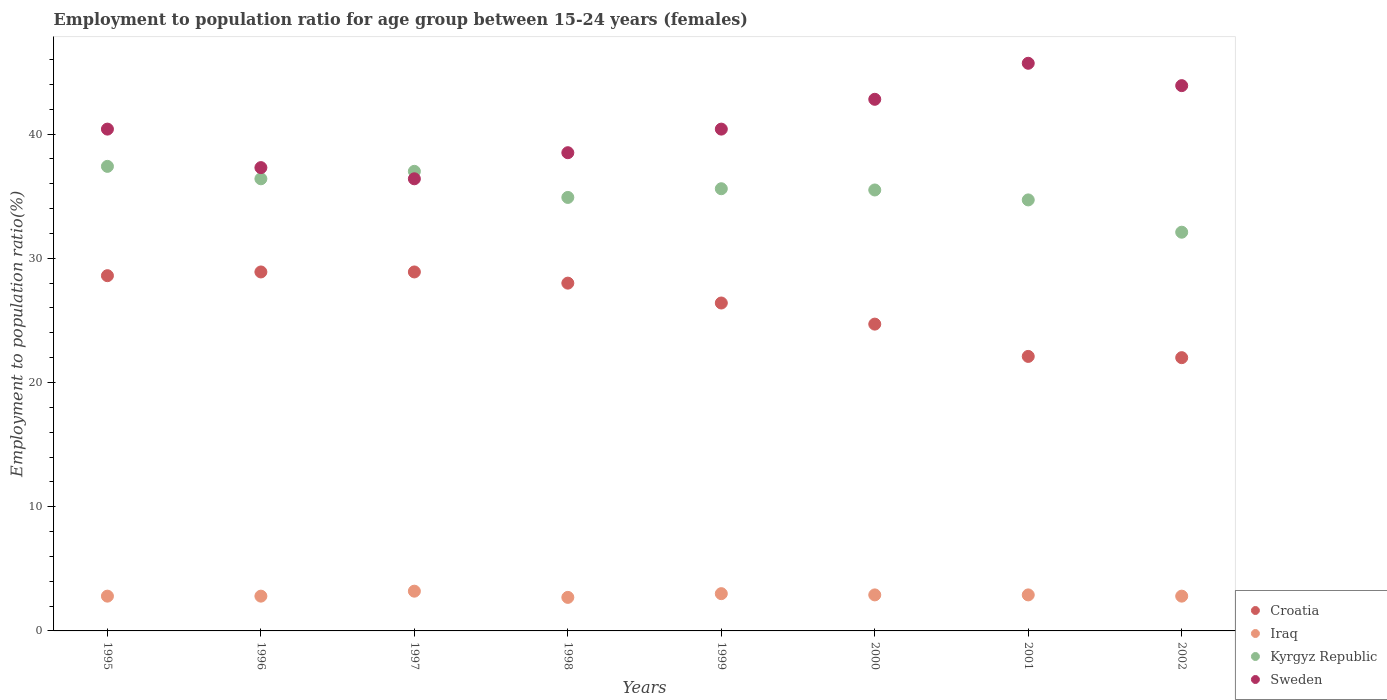Is the number of dotlines equal to the number of legend labels?
Provide a succinct answer. Yes. What is the employment to population ratio in Kyrgyz Republic in 1998?
Offer a terse response. 34.9. Across all years, what is the maximum employment to population ratio in Croatia?
Provide a succinct answer. 28.9. Across all years, what is the minimum employment to population ratio in Croatia?
Offer a very short reply. 22. In which year was the employment to population ratio in Iraq minimum?
Provide a succinct answer. 1998. What is the total employment to population ratio in Sweden in the graph?
Provide a short and direct response. 325.4. What is the difference between the employment to population ratio in Kyrgyz Republic in 2000 and that in 2001?
Provide a short and direct response. 0.8. What is the difference between the employment to population ratio in Kyrgyz Republic in 1997 and the employment to population ratio in Iraq in 2001?
Offer a very short reply. 34.1. What is the average employment to population ratio in Kyrgyz Republic per year?
Your response must be concise. 35.45. In the year 1996, what is the difference between the employment to population ratio in Croatia and employment to population ratio in Sweden?
Provide a succinct answer. -8.4. What is the ratio of the employment to population ratio in Croatia in 1996 to that in 2001?
Give a very brief answer. 1.31. Is the employment to population ratio in Iraq in 1998 less than that in 2002?
Keep it short and to the point. Yes. What is the difference between the highest and the second highest employment to population ratio in Sweden?
Provide a short and direct response. 1.8. What is the difference between the highest and the lowest employment to population ratio in Kyrgyz Republic?
Provide a succinct answer. 5.3. In how many years, is the employment to population ratio in Kyrgyz Republic greater than the average employment to population ratio in Kyrgyz Republic taken over all years?
Make the answer very short. 5. Is it the case that in every year, the sum of the employment to population ratio in Iraq and employment to population ratio in Kyrgyz Republic  is greater than the sum of employment to population ratio in Croatia and employment to population ratio in Sweden?
Make the answer very short. No. Is the employment to population ratio in Sweden strictly greater than the employment to population ratio in Kyrgyz Republic over the years?
Your answer should be very brief. No. How many dotlines are there?
Provide a succinct answer. 4. What is the difference between two consecutive major ticks on the Y-axis?
Make the answer very short. 10. Are the values on the major ticks of Y-axis written in scientific E-notation?
Keep it short and to the point. No. How are the legend labels stacked?
Provide a short and direct response. Vertical. What is the title of the graph?
Your answer should be very brief. Employment to population ratio for age group between 15-24 years (females). What is the label or title of the X-axis?
Your answer should be compact. Years. What is the Employment to population ratio(%) of Croatia in 1995?
Give a very brief answer. 28.6. What is the Employment to population ratio(%) in Iraq in 1995?
Offer a very short reply. 2.8. What is the Employment to population ratio(%) in Kyrgyz Republic in 1995?
Your answer should be very brief. 37.4. What is the Employment to population ratio(%) in Sweden in 1995?
Your response must be concise. 40.4. What is the Employment to population ratio(%) of Croatia in 1996?
Your answer should be very brief. 28.9. What is the Employment to population ratio(%) of Iraq in 1996?
Ensure brevity in your answer.  2.8. What is the Employment to population ratio(%) in Kyrgyz Republic in 1996?
Your response must be concise. 36.4. What is the Employment to population ratio(%) in Sweden in 1996?
Your answer should be compact. 37.3. What is the Employment to population ratio(%) in Croatia in 1997?
Provide a succinct answer. 28.9. What is the Employment to population ratio(%) of Iraq in 1997?
Ensure brevity in your answer.  3.2. What is the Employment to population ratio(%) of Sweden in 1997?
Offer a terse response. 36.4. What is the Employment to population ratio(%) of Croatia in 1998?
Provide a short and direct response. 28. What is the Employment to population ratio(%) of Iraq in 1998?
Your response must be concise. 2.7. What is the Employment to population ratio(%) of Kyrgyz Republic in 1998?
Provide a short and direct response. 34.9. What is the Employment to population ratio(%) in Sweden in 1998?
Offer a very short reply. 38.5. What is the Employment to population ratio(%) in Croatia in 1999?
Your response must be concise. 26.4. What is the Employment to population ratio(%) of Kyrgyz Republic in 1999?
Your response must be concise. 35.6. What is the Employment to population ratio(%) in Sweden in 1999?
Ensure brevity in your answer.  40.4. What is the Employment to population ratio(%) of Croatia in 2000?
Offer a terse response. 24.7. What is the Employment to population ratio(%) in Iraq in 2000?
Your answer should be very brief. 2.9. What is the Employment to population ratio(%) of Kyrgyz Republic in 2000?
Provide a short and direct response. 35.5. What is the Employment to population ratio(%) in Sweden in 2000?
Ensure brevity in your answer.  42.8. What is the Employment to population ratio(%) in Croatia in 2001?
Keep it short and to the point. 22.1. What is the Employment to population ratio(%) in Iraq in 2001?
Offer a terse response. 2.9. What is the Employment to population ratio(%) in Kyrgyz Republic in 2001?
Provide a succinct answer. 34.7. What is the Employment to population ratio(%) of Sweden in 2001?
Your response must be concise. 45.7. What is the Employment to population ratio(%) of Iraq in 2002?
Your answer should be very brief. 2.8. What is the Employment to population ratio(%) in Kyrgyz Republic in 2002?
Ensure brevity in your answer.  32.1. What is the Employment to population ratio(%) in Sweden in 2002?
Provide a short and direct response. 43.9. Across all years, what is the maximum Employment to population ratio(%) of Croatia?
Keep it short and to the point. 28.9. Across all years, what is the maximum Employment to population ratio(%) of Iraq?
Your answer should be compact. 3.2. Across all years, what is the maximum Employment to population ratio(%) in Kyrgyz Republic?
Make the answer very short. 37.4. Across all years, what is the maximum Employment to population ratio(%) of Sweden?
Offer a terse response. 45.7. Across all years, what is the minimum Employment to population ratio(%) in Croatia?
Make the answer very short. 22. Across all years, what is the minimum Employment to population ratio(%) in Iraq?
Offer a very short reply. 2.7. Across all years, what is the minimum Employment to population ratio(%) of Kyrgyz Republic?
Give a very brief answer. 32.1. Across all years, what is the minimum Employment to population ratio(%) in Sweden?
Make the answer very short. 36.4. What is the total Employment to population ratio(%) in Croatia in the graph?
Ensure brevity in your answer.  209.6. What is the total Employment to population ratio(%) in Iraq in the graph?
Provide a succinct answer. 23.1. What is the total Employment to population ratio(%) in Kyrgyz Republic in the graph?
Provide a short and direct response. 283.6. What is the total Employment to population ratio(%) of Sweden in the graph?
Your response must be concise. 325.4. What is the difference between the Employment to population ratio(%) in Kyrgyz Republic in 1995 and that in 1996?
Make the answer very short. 1. What is the difference between the Employment to population ratio(%) in Croatia in 1995 and that in 1997?
Offer a terse response. -0.3. What is the difference between the Employment to population ratio(%) of Sweden in 1995 and that in 1997?
Ensure brevity in your answer.  4. What is the difference between the Employment to population ratio(%) in Iraq in 1995 and that in 1998?
Your answer should be very brief. 0.1. What is the difference between the Employment to population ratio(%) of Iraq in 1995 and that in 1999?
Offer a very short reply. -0.2. What is the difference between the Employment to population ratio(%) in Kyrgyz Republic in 1995 and that in 1999?
Your answer should be compact. 1.8. What is the difference between the Employment to population ratio(%) in Kyrgyz Republic in 1995 and that in 2000?
Provide a succinct answer. 1.9. What is the difference between the Employment to population ratio(%) in Sweden in 1995 and that in 2000?
Your answer should be very brief. -2.4. What is the difference between the Employment to population ratio(%) in Croatia in 1995 and that in 2001?
Your response must be concise. 6.5. What is the difference between the Employment to population ratio(%) of Kyrgyz Republic in 1995 and that in 2001?
Give a very brief answer. 2.7. What is the difference between the Employment to population ratio(%) in Sweden in 1995 and that in 2001?
Offer a very short reply. -5.3. What is the difference between the Employment to population ratio(%) of Kyrgyz Republic in 1995 and that in 2002?
Keep it short and to the point. 5.3. What is the difference between the Employment to population ratio(%) in Croatia in 1996 and that in 1997?
Offer a terse response. 0. What is the difference between the Employment to population ratio(%) of Iraq in 1996 and that in 1997?
Your answer should be very brief. -0.4. What is the difference between the Employment to population ratio(%) of Kyrgyz Republic in 1996 and that in 1997?
Your answer should be compact. -0.6. What is the difference between the Employment to population ratio(%) of Iraq in 1996 and that in 1998?
Provide a short and direct response. 0.1. What is the difference between the Employment to population ratio(%) of Sweden in 1996 and that in 1998?
Offer a very short reply. -1.2. What is the difference between the Employment to population ratio(%) in Croatia in 1996 and that in 1999?
Your response must be concise. 2.5. What is the difference between the Employment to population ratio(%) of Kyrgyz Republic in 1996 and that in 1999?
Your answer should be very brief. 0.8. What is the difference between the Employment to population ratio(%) of Sweden in 1996 and that in 1999?
Provide a succinct answer. -3.1. What is the difference between the Employment to population ratio(%) in Croatia in 1996 and that in 2000?
Provide a succinct answer. 4.2. What is the difference between the Employment to population ratio(%) of Croatia in 1996 and that in 2001?
Offer a terse response. 6.8. What is the difference between the Employment to population ratio(%) of Kyrgyz Republic in 1996 and that in 2001?
Your answer should be compact. 1.7. What is the difference between the Employment to population ratio(%) of Sweden in 1996 and that in 2001?
Offer a terse response. -8.4. What is the difference between the Employment to population ratio(%) in Iraq in 1996 and that in 2002?
Your answer should be very brief. 0. What is the difference between the Employment to population ratio(%) of Sweden in 1996 and that in 2002?
Make the answer very short. -6.6. What is the difference between the Employment to population ratio(%) in Croatia in 1997 and that in 1998?
Your answer should be compact. 0.9. What is the difference between the Employment to population ratio(%) of Iraq in 1997 and that in 1998?
Keep it short and to the point. 0.5. What is the difference between the Employment to population ratio(%) in Kyrgyz Republic in 1997 and that in 1998?
Offer a very short reply. 2.1. What is the difference between the Employment to population ratio(%) in Sweden in 1997 and that in 1998?
Provide a succinct answer. -2.1. What is the difference between the Employment to population ratio(%) of Iraq in 1997 and that in 1999?
Your answer should be very brief. 0.2. What is the difference between the Employment to population ratio(%) of Sweden in 1997 and that in 1999?
Your answer should be very brief. -4. What is the difference between the Employment to population ratio(%) in Kyrgyz Republic in 1997 and that in 2000?
Keep it short and to the point. 1.5. What is the difference between the Employment to population ratio(%) in Sweden in 1997 and that in 2000?
Your response must be concise. -6.4. What is the difference between the Employment to population ratio(%) of Iraq in 1997 and that in 2001?
Ensure brevity in your answer.  0.3. What is the difference between the Employment to population ratio(%) of Sweden in 1997 and that in 2001?
Provide a short and direct response. -9.3. What is the difference between the Employment to population ratio(%) of Iraq in 1997 and that in 2002?
Ensure brevity in your answer.  0.4. What is the difference between the Employment to population ratio(%) of Kyrgyz Republic in 1997 and that in 2002?
Your answer should be very brief. 4.9. What is the difference between the Employment to population ratio(%) of Iraq in 1998 and that in 1999?
Your answer should be compact. -0.3. What is the difference between the Employment to population ratio(%) in Kyrgyz Republic in 1998 and that in 1999?
Make the answer very short. -0.7. What is the difference between the Employment to population ratio(%) in Sweden in 1998 and that in 1999?
Offer a very short reply. -1.9. What is the difference between the Employment to population ratio(%) in Sweden in 1998 and that in 2000?
Your answer should be compact. -4.3. What is the difference between the Employment to population ratio(%) in Croatia in 1998 and that in 2001?
Your answer should be compact. 5.9. What is the difference between the Employment to population ratio(%) in Croatia in 1998 and that in 2002?
Offer a terse response. 6. What is the difference between the Employment to population ratio(%) of Croatia in 1999 and that in 2000?
Offer a very short reply. 1.7. What is the difference between the Employment to population ratio(%) of Kyrgyz Republic in 1999 and that in 2000?
Your response must be concise. 0.1. What is the difference between the Employment to population ratio(%) of Sweden in 1999 and that in 2000?
Provide a succinct answer. -2.4. What is the difference between the Employment to population ratio(%) in Croatia in 1999 and that in 2002?
Provide a succinct answer. 4.4. What is the difference between the Employment to population ratio(%) in Croatia in 2000 and that in 2001?
Give a very brief answer. 2.6. What is the difference between the Employment to population ratio(%) in Iraq in 2000 and that in 2001?
Give a very brief answer. 0. What is the difference between the Employment to population ratio(%) of Kyrgyz Republic in 2000 and that in 2001?
Keep it short and to the point. 0.8. What is the difference between the Employment to population ratio(%) in Croatia in 2000 and that in 2002?
Provide a succinct answer. 2.7. What is the difference between the Employment to population ratio(%) in Sweden in 2000 and that in 2002?
Your answer should be compact. -1.1. What is the difference between the Employment to population ratio(%) of Iraq in 2001 and that in 2002?
Your answer should be compact. 0.1. What is the difference between the Employment to population ratio(%) in Croatia in 1995 and the Employment to population ratio(%) in Iraq in 1996?
Offer a very short reply. 25.8. What is the difference between the Employment to population ratio(%) in Iraq in 1995 and the Employment to population ratio(%) in Kyrgyz Republic in 1996?
Make the answer very short. -33.6. What is the difference between the Employment to population ratio(%) of Iraq in 1995 and the Employment to population ratio(%) of Sweden in 1996?
Keep it short and to the point. -34.5. What is the difference between the Employment to population ratio(%) of Croatia in 1995 and the Employment to population ratio(%) of Iraq in 1997?
Your answer should be compact. 25.4. What is the difference between the Employment to population ratio(%) in Croatia in 1995 and the Employment to population ratio(%) in Kyrgyz Republic in 1997?
Ensure brevity in your answer.  -8.4. What is the difference between the Employment to population ratio(%) of Iraq in 1995 and the Employment to population ratio(%) of Kyrgyz Republic in 1997?
Keep it short and to the point. -34.2. What is the difference between the Employment to population ratio(%) of Iraq in 1995 and the Employment to population ratio(%) of Sweden in 1997?
Your answer should be compact. -33.6. What is the difference between the Employment to population ratio(%) of Kyrgyz Republic in 1995 and the Employment to population ratio(%) of Sweden in 1997?
Make the answer very short. 1. What is the difference between the Employment to population ratio(%) of Croatia in 1995 and the Employment to population ratio(%) of Iraq in 1998?
Keep it short and to the point. 25.9. What is the difference between the Employment to population ratio(%) in Iraq in 1995 and the Employment to population ratio(%) in Kyrgyz Republic in 1998?
Your answer should be compact. -32.1. What is the difference between the Employment to population ratio(%) of Iraq in 1995 and the Employment to population ratio(%) of Sweden in 1998?
Provide a succinct answer. -35.7. What is the difference between the Employment to population ratio(%) of Kyrgyz Republic in 1995 and the Employment to population ratio(%) of Sweden in 1998?
Give a very brief answer. -1.1. What is the difference between the Employment to population ratio(%) in Croatia in 1995 and the Employment to population ratio(%) in Iraq in 1999?
Offer a terse response. 25.6. What is the difference between the Employment to population ratio(%) in Iraq in 1995 and the Employment to population ratio(%) in Kyrgyz Republic in 1999?
Make the answer very short. -32.8. What is the difference between the Employment to population ratio(%) of Iraq in 1995 and the Employment to population ratio(%) of Sweden in 1999?
Offer a very short reply. -37.6. What is the difference between the Employment to population ratio(%) of Kyrgyz Republic in 1995 and the Employment to population ratio(%) of Sweden in 1999?
Provide a short and direct response. -3. What is the difference between the Employment to population ratio(%) of Croatia in 1995 and the Employment to population ratio(%) of Iraq in 2000?
Offer a very short reply. 25.7. What is the difference between the Employment to population ratio(%) of Iraq in 1995 and the Employment to population ratio(%) of Kyrgyz Republic in 2000?
Make the answer very short. -32.7. What is the difference between the Employment to population ratio(%) in Kyrgyz Republic in 1995 and the Employment to population ratio(%) in Sweden in 2000?
Keep it short and to the point. -5.4. What is the difference between the Employment to population ratio(%) in Croatia in 1995 and the Employment to population ratio(%) in Iraq in 2001?
Provide a short and direct response. 25.7. What is the difference between the Employment to population ratio(%) of Croatia in 1995 and the Employment to population ratio(%) of Kyrgyz Republic in 2001?
Offer a very short reply. -6.1. What is the difference between the Employment to population ratio(%) of Croatia in 1995 and the Employment to population ratio(%) of Sweden in 2001?
Provide a succinct answer. -17.1. What is the difference between the Employment to population ratio(%) in Iraq in 1995 and the Employment to population ratio(%) in Kyrgyz Republic in 2001?
Your answer should be very brief. -31.9. What is the difference between the Employment to population ratio(%) of Iraq in 1995 and the Employment to population ratio(%) of Sweden in 2001?
Offer a terse response. -42.9. What is the difference between the Employment to population ratio(%) in Croatia in 1995 and the Employment to population ratio(%) in Iraq in 2002?
Offer a terse response. 25.8. What is the difference between the Employment to population ratio(%) in Croatia in 1995 and the Employment to population ratio(%) in Kyrgyz Republic in 2002?
Your answer should be very brief. -3.5. What is the difference between the Employment to population ratio(%) in Croatia in 1995 and the Employment to population ratio(%) in Sweden in 2002?
Offer a very short reply. -15.3. What is the difference between the Employment to population ratio(%) in Iraq in 1995 and the Employment to population ratio(%) in Kyrgyz Republic in 2002?
Give a very brief answer. -29.3. What is the difference between the Employment to population ratio(%) in Iraq in 1995 and the Employment to population ratio(%) in Sweden in 2002?
Make the answer very short. -41.1. What is the difference between the Employment to population ratio(%) of Croatia in 1996 and the Employment to population ratio(%) of Iraq in 1997?
Keep it short and to the point. 25.7. What is the difference between the Employment to population ratio(%) in Croatia in 1996 and the Employment to population ratio(%) in Sweden in 1997?
Offer a very short reply. -7.5. What is the difference between the Employment to population ratio(%) of Iraq in 1996 and the Employment to population ratio(%) of Kyrgyz Republic in 1997?
Offer a very short reply. -34.2. What is the difference between the Employment to population ratio(%) of Iraq in 1996 and the Employment to population ratio(%) of Sweden in 1997?
Ensure brevity in your answer.  -33.6. What is the difference between the Employment to population ratio(%) of Kyrgyz Republic in 1996 and the Employment to population ratio(%) of Sweden in 1997?
Give a very brief answer. 0. What is the difference between the Employment to population ratio(%) in Croatia in 1996 and the Employment to population ratio(%) in Iraq in 1998?
Your response must be concise. 26.2. What is the difference between the Employment to population ratio(%) in Croatia in 1996 and the Employment to population ratio(%) in Kyrgyz Republic in 1998?
Give a very brief answer. -6. What is the difference between the Employment to population ratio(%) of Iraq in 1996 and the Employment to population ratio(%) of Kyrgyz Republic in 1998?
Ensure brevity in your answer.  -32.1. What is the difference between the Employment to population ratio(%) of Iraq in 1996 and the Employment to population ratio(%) of Sweden in 1998?
Offer a very short reply. -35.7. What is the difference between the Employment to population ratio(%) in Kyrgyz Republic in 1996 and the Employment to population ratio(%) in Sweden in 1998?
Provide a short and direct response. -2.1. What is the difference between the Employment to population ratio(%) in Croatia in 1996 and the Employment to population ratio(%) in Iraq in 1999?
Provide a short and direct response. 25.9. What is the difference between the Employment to population ratio(%) in Croatia in 1996 and the Employment to population ratio(%) in Kyrgyz Republic in 1999?
Your answer should be compact. -6.7. What is the difference between the Employment to population ratio(%) of Croatia in 1996 and the Employment to population ratio(%) of Sweden in 1999?
Keep it short and to the point. -11.5. What is the difference between the Employment to population ratio(%) of Iraq in 1996 and the Employment to population ratio(%) of Kyrgyz Republic in 1999?
Your response must be concise. -32.8. What is the difference between the Employment to population ratio(%) in Iraq in 1996 and the Employment to population ratio(%) in Sweden in 1999?
Your answer should be compact. -37.6. What is the difference between the Employment to population ratio(%) in Kyrgyz Republic in 1996 and the Employment to population ratio(%) in Sweden in 1999?
Your answer should be very brief. -4. What is the difference between the Employment to population ratio(%) in Croatia in 1996 and the Employment to population ratio(%) in Kyrgyz Republic in 2000?
Provide a short and direct response. -6.6. What is the difference between the Employment to population ratio(%) in Iraq in 1996 and the Employment to population ratio(%) in Kyrgyz Republic in 2000?
Ensure brevity in your answer.  -32.7. What is the difference between the Employment to population ratio(%) in Kyrgyz Republic in 1996 and the Employment to population ratio(%) in Sweden in 2000?
Your response must be concise. -6.4. What is the difference between the Employment to population ratio(%) of Croatia in 1996 and the Employment to population ratio(%) of Kyrgyz Republic in 2001?
Your answer should be very brief. -5.8. What is the difference between the Employment to population ratio(%) in Croatia in 1996 and the Employment to population ratio(%) in Sweden in 2001?
Your answer should be compact. -16.8. What is the difference between the Employment to population ratio(%) of Iraq in 1996 and the Employment to population ratio(%) of Kyrgyz Republic in 2001?
Your answer should be very brief. -31.9. What is the difference between the Employment to population ratio(%) of Iraq in 1996 and the Employment to population ratio(%) of Sweden in 2001?
Ensure brevity in your answer.  -42.9. What is the difference between the Employment to population ratio(%) in Kyrgyz Republic in 1996 and the Employment to population ratio(%) in Sweden in 2001?
Your answer should be very brief. -9.3. What is the difference between the Employment to population ratio(%) in Croatia in 1996 and the Employment to population ratio(%) in Iraq in 2002?
Provide a succinct answer. 26.1. What is the difference between the Employment to population ratio(%) in Iraq in 1996 and the Employment to population ratio(%) in Kyrgyz Republic in 2002?
Make the answer very short. -29.3. What is the difference between the Employment to population ratio(%) in Iraq in 1996 and the Employment to population ratio(%) in Sweden in 2002?
Give a very brief answer. -41.1. What is the difference between the Employment to population ratio(%) in Kyrgyz Republic in 1996 and the Employment to population ratio(%) in Sweden in 2002?
Give a very brief answer. -7.5. What is the difference between the Employment to population ratio(%) of Croatia in 1997 and the Employment to population ratio(%) of Iraq in 1998?
Ensure brevity in your answer.  26.2. What is the difference between the Employment to population ratio(%) of Croatia in 1997 and the Employment to population ratio(%) of Kyrgyz Republic in 1998?
Your response must be concise. -6. What is the difference between the Employment to population ratio(%) of Croatia in 1997 and the Employment to population ratio(%) of Sweden in 1998?
Your response must be concise. -9.6. What is the difference between the Employment to population ratio(%) in Iraq in 1997 and the Employment to population ratio(%) in Kyrgyz Republic in 1998?
Provide a succinct answer. -31.7. What is the difference between the Employment to population ratio(%) of Iraq in 1997 and the Employment to population ratio(%) of Sweden in 1998?
Offer a very short reply. -35.3. What is the difference between the Employment to population ratio(%) in Kyrgyz Republic in 1997 and the Employment to population ratio(%) in Sweden in 1998?
Your response must be concise. -1.5. What is the difference between the Employment to population ratio(%) in Croatia in 1997 and the Employment to population ratio(%) in Iraq in 1999?
Ensure brevity in your answer.  25.9. What is the difference between the Employment to population ratio(%) in Croatia in 1997 and the Employment to population ratio(%) in Kyrgyz Republic in 1999?
Offer a terse response. -6.7. What is the difference between the Employment to population ratio(%) in Croatia in 1997 and the Employment to population ratio(%) in Sweden in 1999?
Offer a very short reply. -11.5. What is the difference between the Employment to population ratio(%) of Iraq in 1997 and the Employment to population ratio(%) of Kyrgyz Republic in 1999?
Your answer should be very brief. -32.4. What is the difference between the Employment to population ratio(%) of Iraq in 1997 and the Employment to population ratio(%) of Sweden in 1999?
Give a very brief answer. -37.2. What is the difference between the Employment to population ratio(%) in Croatia in 1997 and the Employment to population ratio(%) in Kyrgyz Republic in 2000?
Make the answer very short. -6.6. What is the difference between the Employment to population ratio(%) in Iraq in 1997 and the Employment to population ratio(%) in Kyrgyz Republic in 2000?
Offer a terse response. -32.3. What is the difference between the Employment to population ratio(%) of Iraq in 1997 and the Employment to population ratio(%) of Sweden in 2000?
Keep it short and to the point. -39.6. What is the difference between the Employment to population ratio(%) in Croatia in 1997 and the Employment to population ratio(%) in Iraq in 2001?
Offer a terse response. 26. What is the difference between the Employment to population ratio(%) in Croatia in 1997 and the Employment to population ratio(%) in Sweden in 2001?
Ensure brevity in your answer.  -16.8. What is the difference between the Employment to population ratio(%) of Iraq in 1997 and the Employment to population ratio(%) of Kyrgyz Republic in 2001?
Offer a terse response. -31.5. What is the difference between the Employment to population ratio(%) of Iraq in 1997 and the Employment to population ratio(%) of Sweden in 2001?
Provide a succinct answer. -42.5. What is the difference between the Employment to population ratio(%) in Kyrgyz Republic in 1997 and the Employment to population ratio(%) in Sweden in 2001?
Your answer should be very brief. -8.7. What is the difference between the Employment to population ratio(%) of Croatia in 1997 and the Employment to population ratio(%) of Iraq in 2002?
Provide a short and direct response. 26.1. What is the difference between the Employment to population ratio(%) in Croatia in 1997 and the Employment to population ratio(%) in Kyrgyz Republic in 2002?
Make the answer very short. -3.2. What is the difference between the Employment to population ratio(%) in Iraq in 1997 and the Employment to population ratio(%) in Kyrgyz Republic in 2002?
Ensure brevity in your answer.  -28.9. What is the difference between the Employment to population ratio(%) of Iraq in 1997 and the Employment to population ratio(%) of Sweden in 2002?
Offer a terse response. -40.7. What is the difference between the Employment to population ratio(%) of Croatia in 1998 and the Employment to population ratio(%) of Iraq in 1999?
Make the answer very short. 25. What is the difference between the Employment to population ratio(%) of Croatia in 1998 and the Employment to population ratio(%) of Kyrgyz Republic in 1999?
Offer a very short reply. -7.6. What is the difference between the Employment to population ratio(%) of Croatia in 1998 and the Employment to population ratio(%) of Sweden in 1999?
Keep it short and to the point. -12.4. What is the difference between the Employment to population ratio(%) of Iraq in 1998 and the Employment to population ratio(%) of Kyrgyz Republic in 1999?
Your response must be concise. -32.9. What is the difference between the Employment to population ratio(%) of Iraq in 1998 and the Employment to population ratio(%) of Sweden in 1999?
Provide a succinct answer. -37.7. What is the difference between the Employment to population ratio(%) in Kyrgyz Republic in 1998 and the Employment to population ratio(%) in Sweden in 1999?
Your answer should be compact. -5.5. What is the difference between the Employment to population ratio(%) in Croatia in 1998 and the Employment to population ratio(%) in Iraq in 2000?
Ensure brevity in your answer.  25.1. What is the difference between the Employment to population ratio(%) in Croatia in 1998 and the Employment to population ratio(%) in Kyrgyz Republic in 2000?
Your response must be concise. -7.5. What is the difference between the Employment to population ratio(%) in Croatia in 1998 and the Employment to population ratio(%) in Sweden in 2000?
Give a very brief answer. -14.8. What is the difference between the Employment to population ratio(%) in Iraq in 1998 and the Employment to population ratio(%) in Kyrgyz Republic in 2000?
Give a very brief answer. -32.8. What is the difference between the Employment to population ratio(%) of Iraq in 1998 and the Employment to population ratio(%) of Sweden in 2000?
Give a very brief answer. -40.1. What is the difference between the Employment to population ratio(%) of Kyrgyz Republic in 1998 and the Employment to population ratio(%) of Sweden in 2000?
Provide a succinct answer. -7.9. What is the difference between the Employment to population ratio(%) in Croatia in 1998 and the Employment to population ratio(%) in Iraq in 2001?
Provide a succinct answer. 25.1. What is the difference between the Employment to population ratio(%) of Croatia in 1998 and the Employment to population ratio(%) of Sweden in 2001?
Your answer should be very brief. -17.7. What is the difference between the Employment to population ratio(%) of Iraq in 1998 and the Employment to population ratio(%) of Kyrgyz Republic in 2001?
Your answer should be very brief. -32. What is the difference between the Employment to population ratio(%) in Iraq in 1998 and the Employment to population ratio(%) in Sweden in 2001?
Your answer should be very brief. -43. What is the difference between the Employment to population ratio(%) in Croatia in 1998 and the Employment to population ratio(%) in Iraq in 2002?
Your answer should be compact. 25.2. What is the difference between the Employment to population ratio(%) of Croatia in 1998 and the Employment to population ratio(%) of Kyrgyz Republic in 2002?
Ensure brevity in your answer.  -4.1. What is the difference between the Employment to population ratio(%) of Croatia in 1998 and the Employment to population ratio(%) of Sweden in 2002?
Keep it short and to the point. -15.9. What is the difference between the Employment to population ratio(%) in Iraq in 1998 and the Employment to population ratio(%) in Kyrgyz Republic in 2002?
Keep it short and to the point. -29.4. What is the difference between the Employment to population ratio(%) of Iraq in 1998 and the Employment to population ratio(%) of Sweden in 2002?
Give a very brief answer. -41.2. What is the difference between the Employment to population ratio(%) of Croatia in 1999 and the Employment to population ratio(%) of Sweden in 2000?
Your answer should be very brief. -16.4. What is the difference between the Employment to population ratio(%) of Iraq in 1999 and the Employment to population ratio(%) of Kyrgyz Republic in 2000?
Provide a succinct answer. -32.5. What is the difference between the Employment to population ratio(%) in Iraq in 1999 and the Employment to population ratio(%) in Sweden in 2000?
Your answer should be compact. -39.8. What is the difference between the Employment to population ratio(%) of Kyrgyz Republic in 1999 and the Employment to population ratio(%) of Sweden in 2000?
Your answer should be compact. -7.2. What is the difference between the Employment to population ratio(%) in Croatia in 1999 and the Employment to population ratio(%) in Sweden in 2001?
Your response must be concise. -19.3. What is the difference between the Employment to population ratio(%) in Iraq in 1999 and the Employment to population ratio(%) in Kyrgyz Republic in 2001?
Your answer should be very brief. -31.7. What is the difference between the Employment to population ratio(%) of Iraq in 1999 and the Employment to population ratio(%) of Sweden in 2001?
Your response must be concise. -42.7. What is the difference between the Employment to population ratio(%) of Kyrgyz Republic in 1999 and the Employment to population ratio(%) of Sweden in 2001?
Make the answer very short. -10.1. What is the difference between the Employment to population ratio(%) in Croatia in 1999 and the Employment to population ratio(%) in Iraq in 2002?
Offer a very short reply. 23.6. What is the difference between the Employment to population ratio(%) in Croatia in 1999 and the Employment to population ratio(%) in Sweden in 2002?
Give a very brief answer. -17.5. What is the difference between the Employment to population ratio(%) of Iraq in 1999 and the Employment to population ratio(%) of Kyrgyz Republic in 2002?
Provide a succinct answer. -29.1. What is the difference between the Employment to population ratio(%) of Iraq in 1999 and the Employment to population ratio(%) of Sweden in 2002?
Make the answer very short. -40.9. What is the difference between the Employment to population ratio(%) in Croatia in 2000 and the Employment to population ratio(%) in Iraq in 2001?
Give a very brief answer. 21.8. What is the difference between the Employment to population ratio(%) of Croatia in 2000 and the Employment to population ratio(%) of Sweden in 2001?
Give a very brief answer. -21. What is the difference between the Employment to population ratio(%) of Iraq in 2000 and the Employment to population ratio(%) of Kyrgyz Republic in 2001?
Offer a terse response. -31.8. What is the difference between the Employment to population ratio(%) of Iraq in 2000 and the Employment to population ratio(%) of Sweden in 2001?
Your answer should be compact. -42.8. What is the difference between the Employment to population ratio(%) of Croatia in 2000 and the Employment to population ratio(%) of Iraq in 2002?
Your answer should be compact. 21.9. What is the difference between the Employment to population ratio(%) of Croatia in 2000 and the Employment to population ratio(%) of Kyrgyz Republic in 2002?
Keep it short and to the point. -7.4. What is the difference between the Employment to population ratio(%) of Croatia in 2000 and the Employment to population ratio(%) of Sweden in 2002?
Offer a very short reply. -19.2. What is the difference between the Employment to population ratio(%) in Iraq in 2000 and the Employment to population ratio(%) in Kyrgyz Republic in 2002?
Offer a terse response. -29.2. What is the difference between the Employment to population ratio(%) of Iraq in 2000 and the Employment to population ratio(%) of Sweden in 2002?
Provide a short and direct response. -41. What is the difference between the Employment to population ratio(%) in Croatia in 2001 and the Employment to population ratio(%) in Iraq in 2002?
Provide a succinct answer. 19.3. What is the difference between the Employment to population ratio(%) of Croatia in 2001 and the Employment to population ratio(%) of Sweden in 2002?
Your response must be concise. -21.8. What is the difference between the Employment to population ratio(%) of Iraq in 2001 and the Employment to population ratio(%) of Kyrgyz Republic in 2002?
Offer a very short reply. -29.2. What is the difference between the Employment to population ratio(%) of Iraq in 2001 and the Employment to population ratio(%) of Sweden in 2002?
Your answer should be very brief. -41. What is the difference between the Employment to population ratio(%) in Kyrgyz Republic in 2001 and the Employment to population ratio(%) in Sweden in 2002?
Your response must be concise. -9.2. What is the average Employment to population ratio(%) of Croatia per year?
Give a very brief answer. 26.2. What is the average Employment to population ratio(%) of Iraq per year?
Make the answer very short. 2.89. What is the average Employment to population ratio(%) in Kyrgyz Republic per year?
Your answer should be compact. 35.45. What is the average Employment to population ratio(%) in Sweden per year?
Keep it short and to the point. 40.67. In the year 1995, what is the difference between the Employment to population ratio(%) in Croatia and Employment to population ratio(%) in Iraq?
Ensure brevity in your answer.  25.8. In the year 1995, what is the difference between the Employment to population ratio(%) in Croatia and Employment to population ratio(%) in Sweden?
Offer a very short reply. -11.8. In the year 1995, what is the difference between the Employment to population ratio(%) in Iraq and Employment to population ratio(%) in Kyrgyz Republic?
Your answer should be very brief. -34.6. In the year 1995, what is the difference between the Employment to population ratio(%) in Iraq and Employment to population ratio(%) in Sweden?
Offer a terse response. -37.6. In the year 1995, what is the difference between the Employment to population ratio(%) of Kyrgyz Republic and Employment to population ratio(%) of Sweden?
Keep it short and to the point. -3. In the year 1996, what is the difference between the Employment to population ratio(%) of Croatia and Employment to population ratio(%) of Iraq?
Keep it short and to the point. 26.1. In the year 1996, what is the difference between the Employment to population ratio(%) in Croatia and Employment to population ratio(%) in Kyrgyz Republic?
Make the answer very short. -7.5. In the year 1996, what is the difference between the Employment to population ratio(%) of Croatia and Employment to population ratio(%) of Sweden?
Make the answer very short. -8.4. In the year 1996, what is the difference between the Employment to population ratio(%) of Iraq and Employment to population ratio(%) of Kyrgyz Republic?
Ensure brevity in your answer.  -33.6. In the year 1996, what is the difference between the Employment to population ratio(%) in Iraq and Employment to population ratio(%) in Sweden?
Offer a very short reply. -34.5. In the year 1996, what is the difference between the Employment to population ratio(%) in Kyrgyz Republic and Employment to population ratio(%) in Sweden?
Your response must be concise. -0.9. In the year 1997, what is the difference between the Employment to population ratio(%) in Croatia and Employment to population ratio(%) in Iraq?
Give a very brief answer. 25.7. In the year 1997, what is the difference between the Employment to population ratio(%) of Iraq and Employment to population ratio(%) of Kyrgyz Republic?
Provide a short and direct response. -33.8. In the year 1997, what is the difference between the Employment to population ratio(%) of Iraq and Employment to population ratio(%) of Sweden?
Make the answer very short. -33.2. In the year 1997, what is the difference between the Employment to population ratio(%) in Kyrgyz Republic and Employment to population ratio(%) in Sweden?
Give a very brief answer. 0.6. In the year 1998, what is the difference between the Employment to population ratio(%) of Croatia and Employment to population ratio(%) of Iraq?
Your answer should be very brief. 25.3. In the year 1998, what is the difference between the Employment to population ratio(%) in Croatia and Employment to population ratio(%) in Sweden?
Ensure brevity in your answer.  -10.5. In the year 1998, what is the difference between the Employment to population ratio(%) of Iraq and Employment to population ratio(%) of Kyrgyz Republic?
Your answer should be compact. -32.2. In the year 1998, what is the difference between the Employment to population ratio(%) in Iraq and Employment to population ratio(%) in Sweden?
Make the answer very short. -35.8. In the year 1998, what is the difference between the Employment to population ratio(%) in Kyrgyz Republic and Employment to population ratio(%) in Sweden?
Ensure brevity in your answer.  -3.6. In the year 1999, what is the difference between the Employment to population ratio(%) in Croatia and Employment to population ratio(%) in Iraq?
Your answer should be very brief. 23.4. In the year 1999, what is the difference between the Employment to population ratio(%) in Croatia and Employment to population ratio(%) in Kyrgyz Republic?
Keep it short and to the point. -9.2. In the year 1999, what is the difference between the Employment to population ratio(%) of Croatia and Employment to population ratio(%) of Sweden?
Offer a terse response. -14. In the year 1999, what is the difference between the Employment to population ratio(%) of Iraq and Employment to population ratio(%) of Kyrgyz Republic?
Provide a succinct answer. -32.6. In the year 1999, what is the difference between the Employment to population ratio(%) of Iraq and Employment to population ratio(%) of Sweden?
Offer a terse response. -37.4. In the year 1999, what is the difference between the Employment to population ratio(%) in Kyrgyz Republic and Employment to population ratio(%) in Sweden?
Your response must be concise. -4.8. In the year 2000, what is the difference between the Employment to population ratio(%) of Croatia and Employment to population ratio(%) of Iraq?
Provide a succinct answer. 21.8. In the year 2000, what is the difference between the Employment to population ratio(%) in Croatia and Employment to population ratio(%) in Kyrgyz Republic?
Provide a succinct answer. -10.8. In the year 2000, what is the difference between the Employment to population ratio(%) of Croatia and Employment to population ratio(%) of Sweden?
Make the answer very short. -18.1. In the year 2000, what is the difference between the Employment to population ratio(%) in Iraq and Employment to population ratio(%) in Kyrgyz Republic?
Provide a succinct answer. -32.6. In the year 2000, what is the difference between the Employment to population ratio(%) of Iraq and Employment to population ratio(%) of Sweden?
Your answer should be compact. -39.9. In the year 2000, what is the difference between the Employment to population ratio(%) of Kyrgyz Republic and Employment to population ratio(%) of Sweden?
Keep it short and to the point. -7.3. In the year 2001, what is the difference between the Employment to population ratio(%) in Croatia and Employment to population ratio(%) in Kyrgyz Republic?
Make the answer very short. -12.6. In the year 2001, what is the difference between the Employment to population ratio(%) in Croatia and Employment to population ratio(%) in Sweden?
Your answer should be very brief. -23.6. In the year 2001, what is the difference between the Employment to population ratio(%) of Iraq and Employment to population ratio(%) of Kyrgyz Republic?
Provide a succinct answer. -31.8. In the year 2001, what is the difference between the Employment to population ratio(%) in Iraq and Employment to population ratio(%) in Sweden?
Your answer should be very brief. -42.8. In the year 2001, what is the difference between the Employment to population ratio(%) in Kyrgyz Republic and Employment to population ratio(%) in Sweden?
Make the answer very short. -11. In the year 2002, what is the difference between the Employment to population ratio(%) of Croatia and Employment to population ratio(%) of Iraq?
Your answer should be very brief. 19.2. In the year 2002, what is the difference between the Employment to population ratio(%) in Croatia and Employment to population ratio(%) in Sweden?
Keep it short and to the point. -21.9. In the year 2002, what is the difference between the Employment to population ratio(%) in Iraq and Employment to population ratio(%) in Kyrgyz Republic?
Your answer should be very brief. -29.3. In the year 2002, what is the difference between the Employment to population ratio(%) of Iraq and Employment to population ratio(%) of Sweden?
Make the answer very short. -41.1. What is the ratio of the Employment to population ratio(%) in Croatia in 1995 to that in 1996?
Provide a short and direct response. 0.99. What is the ratio of the Employment to population ratio(%) in Iraq in 1995 to that in 1996?
Ensure brevity in your answer.  1. What is the ratio of the Employment to population ratio(%) of Kyrgyz Republic in 1995 to that in 1996?
Your answer should be compact. 1.03. What is the ratio of the Employment to population ratio(%) in Sweden in 1995 to that in 1996?
Ensure brevity in your answer.  1.08. What is the ratio of the Employment to population ratio(%) in Croatia in 1995 to that in 1997?
Provide a short and direct response. 0.99. What is the ratio of the Employment to population ratio(%) of Kyrgyz Republic in 1995 to that in 1997?
Keep it short and to the point. 1.01. What is the ratio of the Employment to population ratio(%) in Sweden in 1995 to that in 1997?
Provide a succinct answer. 1.11. What is the ratio of the Employment to population ratio(%) of Croatia in 1995 to that in 1998?
Ensure brevity in your answer.  1.02. What is the ratio of the Employment to population ratio(%) in Iraq in 1995 to that in 1998?
Ensure brevity in your answer.  1.04. What is the ratio of the Employment to population ratio(%) of Kyrgyz Republic in 1995 to that in 1998?
Your answer should be compact. 1.07. What is the ratio of the Employment to population ratio(%) of Sweden in 1995 to that in 1998?
Your answer should be compact. 1.05. What is the ratio of the Employment to population ratio(%) of Kyrgyz Republic in 1995 to that in 1999?
Your answer should be very brief. 1.05. What is the ratio of the Employment to population ratio(%) of Sweden in 1995 to that in 1999?
Provide a succinct answer. 1. What is the ratio of the Employment to population ratio(%) of Croatia in 1995 to that in 2000?
Give a very brief answer. 1.16. What is the ratio of the Employment to population ratio(%) of Iraq in 1995 to that in 2000?
Offer a terse response. 0.97. What is the ratio of the Employment to population ratio(%) of Kyrgyz Republic in 1995 to that in 2000?
Offer a very short reply. 1.05. What is the ratio of the Employment to population ratio(%) of Sweden in 1995 to that in 2000?
Give a very brief answer. 0.94. What is the ratio of the Employment to population ratio(%) of Croatia in 1995 to that in 2001?
Provide a short and direct response. 1.29. What is the ratio of the Employment to population ratio(%) of Iraq in 1995 to that in 2001?
Keep it short and to the point. 0.97. What is the ratio of the Employment to population ratio(%) in Kyrgyz Republic in 1995 to that in 2001?
Ensure brevity in your answer.  1.08. What is the ratio of the Employment to population ratio(%) in Sweden in 1995 to that in 2001?
Ensure brevity in your answer.  0.88. What is the ratio of the Employment to population ratio(%) in Croatia in 1995 to that in 2002?
Make the answer very short. 1.3. What is the ratio of the Employment to population ratio(%) in Iraq in 1995 to that in 2002?
Your answer should be very brief. 1. What is the ratio of the Employment to population ratio(%) in Kyrgyz Republic in 1995 to that in 2002?
Make the answer very short. 1.17. What is the ratio of the Employment to population ratio(%) in Sweden in 1995 to that in 2002?
Offer a very short reply. 0.92. What is the ratio of the Employment to population ratio(%) of Croatia in 1996 to that in 1997?
Your answer should be compact. 1. What is the ratio of the Employment to population ratio(%) in Kyrgyz Republic in 1996 to that in 1997?
Ensure brevity in your answer.  0.98. What is the ratio of the Employment to population ratio(%) of Sweden in 1996 to that in 1997?
Make the answer very short. 1.02. What is the ratio of the Employment to population ratio(%) of Croatia in 1996 to that in 1998?
Make the answer very short. 1.03. What is the ratio of the Employment to population ratio(%) of Iraq in 1996 to that in 1998?
Your answer should be compact. 1.04. What is the ratio of the Employment to population ratio(%) in Kyrgyz Republic in 1996 to that in 1998?
Provide a succinct answer. 1.04. What is the ratio of the Employment to population ratio(%) in Sweden in 1996 to that in 1998?
Provide a succinct answer. 0.97. What is the ratio of the Employment to population ratio(%) in Croatia in 1996 to that in 1999?
Offer a terse response. 1.09. What is the ratio of the Employment to population ratio(%) of Iraq in 1996 to that in 1999?
Offer a very short reply. 0.93. What is the ratio of the Employment to population ratio(%) of Kyrgyz Republic in 1996 to that in 1999?
Give a very brief answer. 1.02. What is the ratio of the Employment to population ratio(%) of Sweden in 1996 to that in 1999?
Offer a very short reply. 0.92. What is the ratio of the Employment to population ratio(%) of Croatia in 1996 to that in 2000?
Make the answer very short. 1.17. What is the ratio of the Employment to population ratio(%) in Iraq in 1996 to that in 2000?
Make the answer very short. 0.97. What is the ratio of the Employment to population ratio(%) in Kyrgyz Republic in 1996 to that in 2000?
Ensure brevity in your answer.  1.03. What is the ratio of the Employment to population ratio(%) in Sweden in 1996 to that in 2000?
Offer a terse response. 0.87. What is the ratio of the Employment to population ratio(%) of Croatia in 1996 to that in 2001?
Provide a succinct answer. 1.31. What is the ratio of the Employment to population ratio(%) of Iraq in 1996 to that in 2001?
Offer a very short reply. 0.97. What is the ratio of the Employment to population ratio(%) of Kyrgyz Republic in 1996 to that in 2001?
Provide a short and direct response. 1.05. What is the ratio of the Employment to population ratio(%) in Sweden in 1996 to that in 2001?
Make the answer very short. 0.82. What is the ratio of the Employment to population ratio(%) in Croatia in 1996 to that in 2002?
Your answer should be compact. 1.31. What is the ratio of the Employment to population ratio(%) in Kyrgyz Republic in 1996 to that in 2002?
Your response must be concise. 1.13. What is the ratio of the Employment to population ratio(%) in Sweden in 1996 to that in 2002?
Provide a short and direct response. 0.85. What is the ratio of the Employment to population ratio(%) of Croatia in 1997 to that in 1998?
Give a very brief answer. 1.03. What is the ratio of the Employment to population ratio(%) of Iraq in 1997 to that in 1998?
Your response must be concise. 1.19. What is the ratio of the Employment to population ratio(%) in Kyrgyz Republic in 1997 to that in 1998?
Your answer should be very brief. 1.06. What is the ratio of the Employment to population ratio(%) of Sweden in 1997 to that in 1998?
Offer a terse response. 0.95. What is the ratio of the Employment to population ratio(%) in Croatia in 1997 to that in 1999?
Your response must be concise. 1.09. What is the ratio of the Employment to population ratio(%) in Iraq in 1997 to that in 1999?
Offer a terse response. 1.07. What is the ratio of the Employment to population ratio(%) in Kyrgyz Republic in 1997 to that in 1999?
Offer a very short reply. 1.04. What is the ratio of the Employment to population ratio(%) of Sweden in 1997 to that in 1999?
Your response must be concise. 0.9. What is the ratio of the Employment to population ratio(%) in Croatia in 1997 to that in 2000?
Offer a very short reply. 1.17. What is the ratio of the Employment to population ratio(%) in Iraq in 1997 to that in 2000?
Offer a very short reply. 1.1. What is the ratio of the Employment to population ratio(%) in Kyrgyz Republic in 1997 to that in 2000?
Provide a succinct answer. 1.04. What is the ratio of the Employment to population ratio(%) of Sweden in 1997 to that in 2000?
Keep it short and to the point. 0.85. What is the ratio of the Employment to population ratio(%) in Croatia in 1997 to that in 2001?
Your answer should be very brief. 1.31. What is the ratio of the Employment to population ratio(%) in Iraq in 1997 to that in 2001?
Offer a very short reply. 1.1. What is the ratio of the Employment to population ratio(%) of Kyrgyz Republic in 1997 to that in 2001?
Your answer should be compact. 1.07. What is the ratio of the Employment to population ratio(%) in Sweden in 1997 to that in 2001?
Your answer should be very brief. 0.8. What is the ratio of the Employment to population ratio(%) in Croatia in 1997 to that in 2002?
Offer a very short reply. 1.31. What is the ratio of the Employment to population ratio(%) of Iraq in 1997 to that in 2002?
Give a very brief answer. 1.14. What is the ratio of the Employment to population ratio(%) in Kyrgyz Republic in 1997 to that in 2002?
Your answer should be very brief. 1.15. What is the ratio of the Employment to population ratio(%) in Sweden in 1997 to that in 2002?
Your response must be concise. 0.83. What is the ratio of the Employment to population ratio(%) in Croatia in 1998 to that in 1999?
Provide a short and direct response. 1.06. What is the ratio of the Employment to population ratio(%) of Kyrgyz Republic in 1998 to that in 1999?
Make the answer very short. 0.98. What is the ratio of the Employment to population ratio(%) of Sweden in 1998 to that in 1999?
Offer a terse response. 0.95. What is the ratio of the Employment to population ratio(%) of Croatia in 1998 to that in 2000?
Keep it short and to the point. 1.13. What is the ratio of the Employment to population ratio(%) in Kyrgyz Republic in 1998 to that in 2000?
Your answer should be very brief. 0.98. What is the ratio of the Employment to population ratio(%) in Sweden in 1998 to that in 2000?
Ensure brevity in your answer.  0.9. What is the ratio of the Employment to population ratio(%) of Croatia in 1998 to that in 2001?
Your answer should be very brief. 1.27. What is the ratio of the Employment to population ratio(%) in Iraq in 1998 to that in 2001?
Keep it short and to the point. 0.93. What is the ratio of the Employment to population ratio(%) of Kyrgyz Republic in 1998 to that in 2001?
Provide a short and direct response. 1.01. What is the ratio of the Employment to population ratio(%) of Sweden in 1998 to that in 2001?
Your answer should be compact. 0.84. What is the ratio of the Employment to population ratio(%) of Croatia in 1998 to that in 2002?
Offer a terse response. 1.27. What is the ratio of the Employment to population ratio(%) in Kyrgyz Republic in 1998 to that in 2002?
Offer a terse response. 1.09. What is the ratio of the Employment to population ratio(%) of Sweden in 1998 to that in 2002?
Give a very brief answer. 0.88. What is the ratio of the Employment to population ratio(%) in Croatia in 1999 to that in 2000?
Your response must be concise. 1.07. What is the ratio of the Employment to population ratio(%) of Iraq in 1999 to that in 2000?
Provide a succinct answer. 1.03. What is the ratio of the Employment to population ratio(%) of Kyrgyz Republic in 1999 to that in 2000?
Make the answer very short. 1. What is the ratio of the Employment to population ratio(%) in Sweden in 1999 to that in 2000?
Give a very brief answer. 0.94. What is the ratio of the Employment to population ratio(%) in Croatia in 1999 to that in 2001?
Provide a short and direct response. 1.19. What is the ratio of the Employment to population ratio(%) in Iraq in 1999 to that in 2001?
Keep it short and to the point. 1.03. What is the ratio of the Employment to population ratio(%) in Kyrgyz Republic in 1999 to that in 2001?
Your response must be concise. 1.03. What is the ratio of the Employment to population ratio(%) of Sweden in 1999 to that in 2001?
Keep it short and to the point. 0.88. What is the ratio of the Employment to population ratio(%) in Croatia in 1999 to that in 2002?
Your answer should be compact. 1.2. What is the ratio of the Employment to population ratio(%) in Iraq in 1999 to that in 2002?
Offer a terse response. 1.07. What is the ratio of the Employment to population ratio(%) in Kyrgyz Republic in 1999 to that in 2002?
Your answer should be very brief. 1.11. What is the ratio of the Employment to population ratio(%) of Sweden in 1999 to that in 2002?
Offer a very short reply. 0.92. What is the ratio of the Employment to population ratio(%) of Croatia in 2000 to that in 2001?
Provide a succinct answer. 1.12. What is the ratio of the Employment to population ratio(%) in Iraq in 2000 to that in 2001?
Keep it short and to the point. 1. What is the ratio of the Employment to population ratio(%) of Kyrgyz Republic in 2000 to that in 2001?
Provide a succinct answer. 1.02. What is the ratio of the Employment to population ratio(%) of Sweden in 2000 to that in 2001?
Your response must be concise. 0.94. What is the ratio of the Employment to population ratio(%) of Croatia in 2000 to that in 2002?
Make the answer very short. 1.12. What is the ratio of the Employment to population ratio(%) in Iraq in 2000 to that in 2002?
Your answer should be compact. 1.04. What is the ratio of the Employment to population ratio(%) in Kyrgyz Republic in 2000 to that in 2002?
Ensure brevity in your answer.  1.11. What is the ratio of the Employment to population ratio(%) in Sweden in 2000 to that in 2002?
Give a very brief answer. 0.97. What is the ratio of the Employment to population ratio(%) in Iraq in 2001 to that in 2002?
Make the answer very short. 1.04. What is the ratio of the Employment to population ratio(%) in Kyrgyz Republic in 2001 to that in 2002?
Provide a succinct answer. 1.08. What is the ratio of the Employment to population ratio(%) of Sweden in 2001 to that in 2002?
Ensure brevity in your answer.  1.04. What is the difference between the highest and the second highest Employment to population ratio(%) in Iraq?
Offer a very short reply. 0.2. What is the difference between the highest and the second highest Employment to population ratio(%) of Kyrgyz Republic?
Ensure brevity in your answer.  0.4. What is the difference between the highest and the lowest Employment to population ratio(%) in Iraq?
Your response must be concise. 0.5. What is the difference between the highest and the lowest Employment to population ratio(%) in Kyrgyz Republic?
Ensure brevity in your answer.  5.3. 